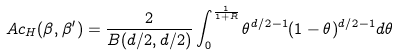<formula> <loc_0><loc_0><loc_500><loc_500>A c _ { H } ( \beta , \beta ^ { \prime } ) = \frac { 2 } { B ( d / 2 , d / 2 ) } \int _ { 0 } ^ { \frac { 1 } { 1 + R } } \theta ^ { d / 2 - 1 } ( 1 - \theta ) ^ { d / 2 - 1 } d \theta</formula> 